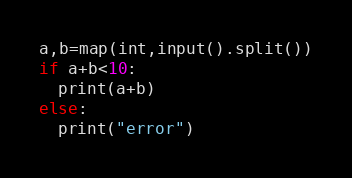<code> <loc_0><loc_0><loc_500><loc_500><_Python_>a,b=map(int,input().split())
if a+b<10:
  print(a+b)
else:
  print("error")</code> 